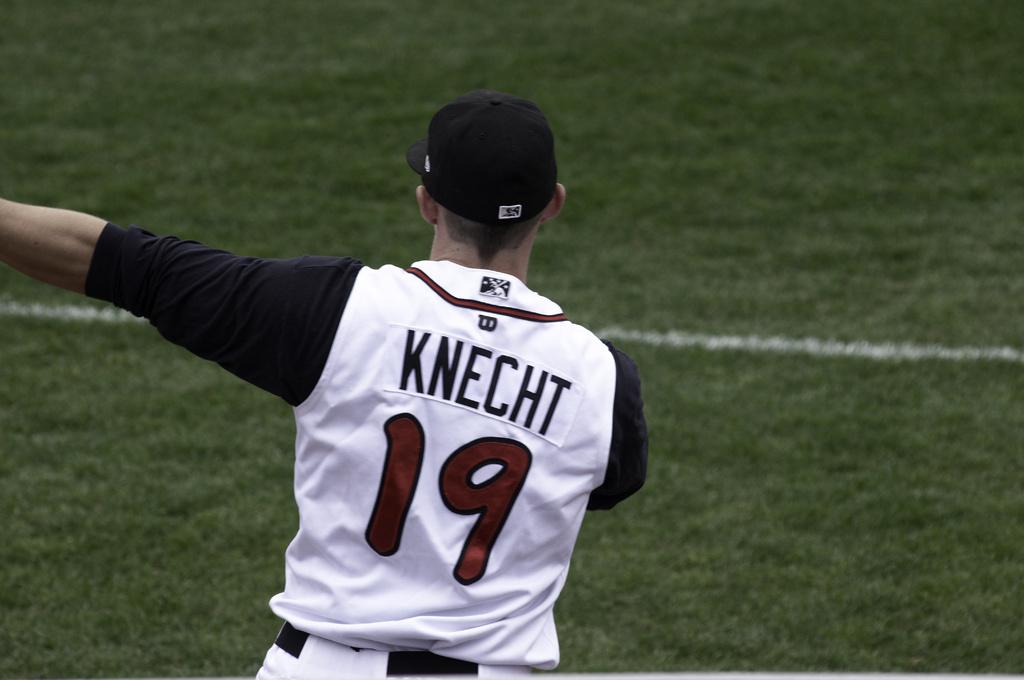What is the name of this baseball player?
Your answer should be compact. Knecht. What number is knecht?
Make the answer very short. 19. 